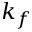<formula> <loc_0><loc_0><loc_500><loc_500>k _ { f }</formula> 